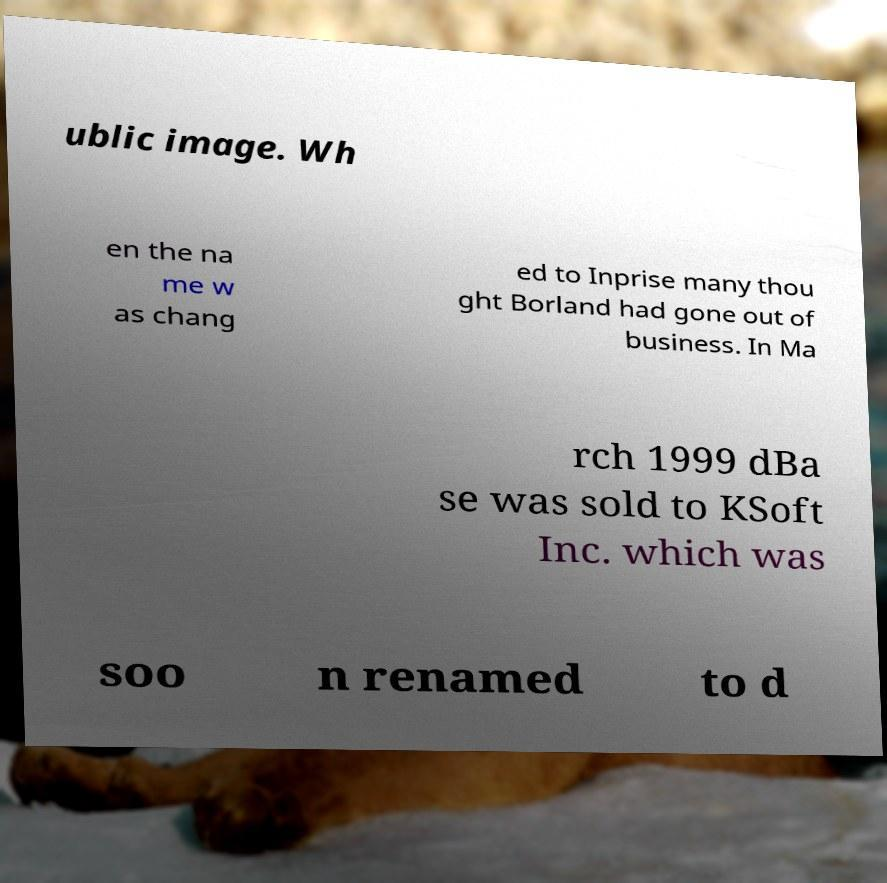Can you accurately transcribe the text from the provided image for me? ublic image. Wh en the na me w as chang ed to Inprise many thou ght Borland had gone out of business. In Ma rch 1999 dBa se was sold to KSoft Inc. which was soo n renamed to d 